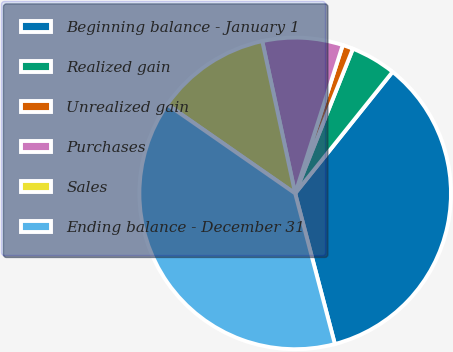Convert chart to OTSL. <chart><loc_0><loc_0><loc_500><loc_500><pie_chart><fcel>Beginning balance - January 1<fcel>Realized gain<fcel>Unrealized gain<fcel>Purchases<fcel>Sales<fcel>Ending balance - December 31<nl><fcel>35.15%<fcel>4.71%<fcel>1.1%<fcel>8.33%<fcel>11.94%<fcel>38.77%<nl></chart> 